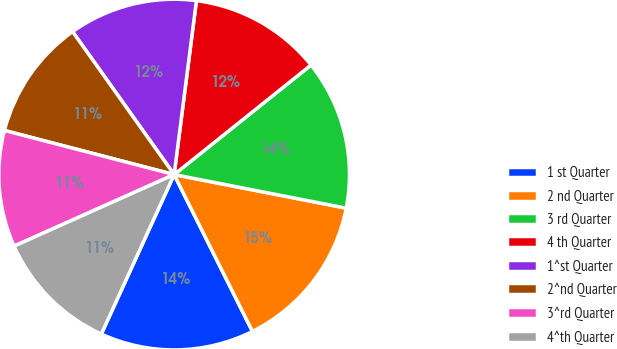Convert chart to OTSL. <chart><loc_0><loc_0><loc_500><loc_500><pie_chart><fcel>1 st Quarter<fcel>2 nd Quarter<fcel>3 rd Quarter<fcel>4 th Quarter<fcel>1^st Quarter<fcel>2^nd Quarter<fcel>3^rd Quarter<fcel>4^th Quarter<nl><fcel>14.19%<fcel>14.56%<fcel>13.81%<fcel>12.23%<fcel>11.86%<fcel>11.12%<fcel>10.74%<fcel>11.49%<nl></chart> 